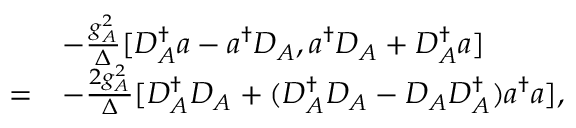<formula> <loc_0><loc_0><loc_500><loc_500>\begin{array} { r l } & { - \frac { g _ { A } ^ { 2 } } { \Delta } [ D _ { A } ^ { \dagger } a - a ^ { \dagger } D _ { A } , a ^ { \dagger } D _ { A } + D _ { A } ^ { \dagger } a ] } \\ { = } & { - \frac { 2 g _ { A } ^ { 2 } } { \Delta } [ D _ { A } ^ { \dagger } D _ { A } + ( D _ { A } ^ { \dagger } D _ { A } - D _ { A } D _ { A } ^ { \dagger } ) a ^ { \dagger } a ] , } \end{array}</formula> 